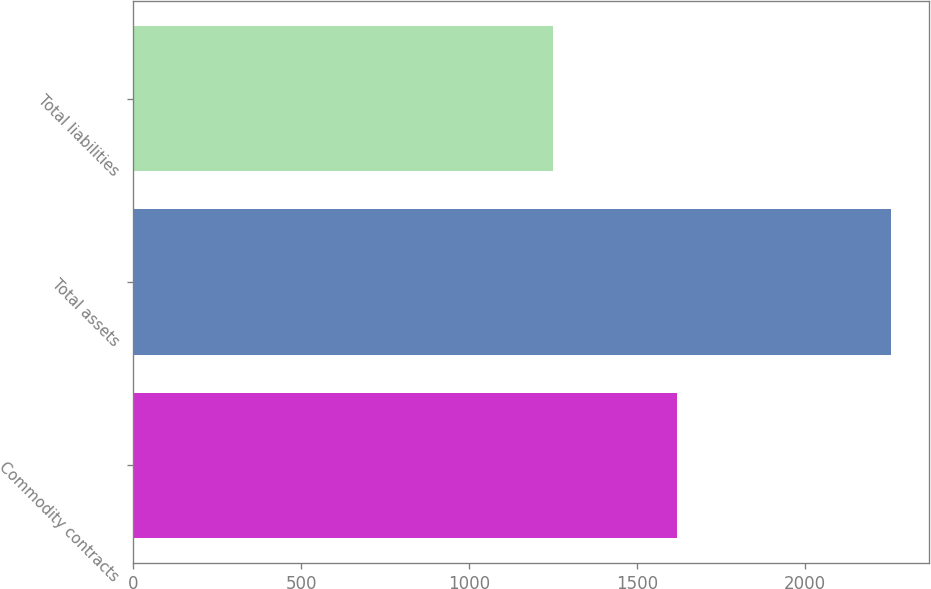Convert chart. <chart><loc_0><loc_0><loc_500><loc_500><bar_chart><fcel>Commodity contracts<fcel>Total assets<fcel>Total liabilities<nl><fcel>1619<fcel>2256<fcel>1250<nl></chart> 